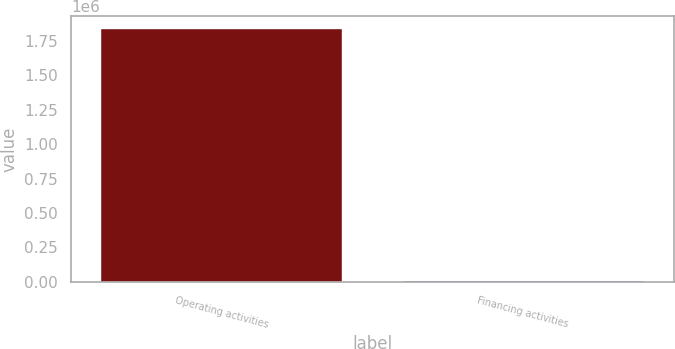Convert chart to OTSL. <chart><loc_0><loc_0><loc_500><loc_500><bar_chart><fcel>Operating activities<fcel>Financing activities<nl><fcel>1.83746e+06<fcel>5217<nl></chart> 